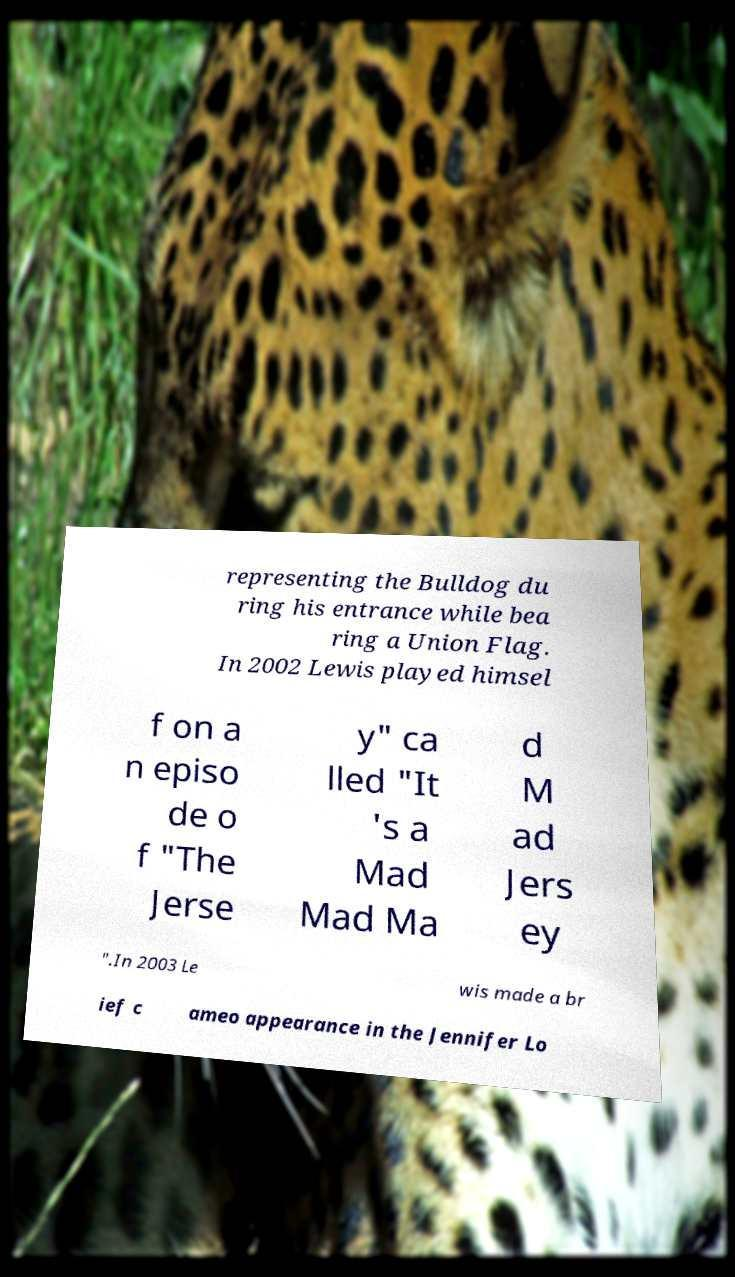Please identify and transcribe the text found in this image. representing the Bulldog du ring his entrance while bea ring a Union Flag. In 2002 Lewis played himsel f on a n episo de o f "The Jerse y" ca lled "It 's a Mad Mad Ma d M ad Jers ey ".In 2003 Le wis made a br ief c ameo appearance in the Jennifer Lo 